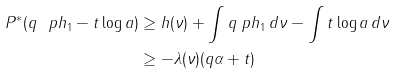Convert formula to latex. <formula><loc_0><loc_0><loc_500><loc_500>P ^ { * } ( q \ p h _ { 1 } - t \log a ) & \geq h ( \nu ) + \int q \ p h _ { 1 } \, d \nu - \int t \log a \, d \nu \\ & \geq - \lambda ( \nu ) ( q \alpha + t )</formula> 